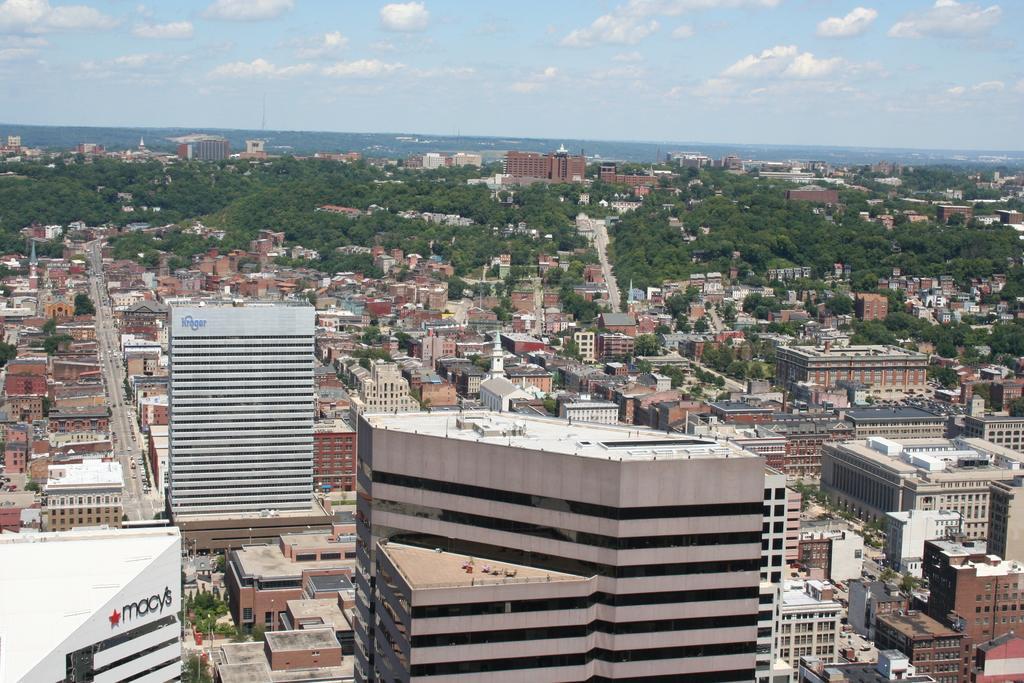How would you summarize this image in a sentence or two? At the bottom of the picture, we see the buildings in white and grey color. There are buildings, trees and hills in the background. At the top of the picture, we see the sky and the clouds. This picture is clicked outside the city. 